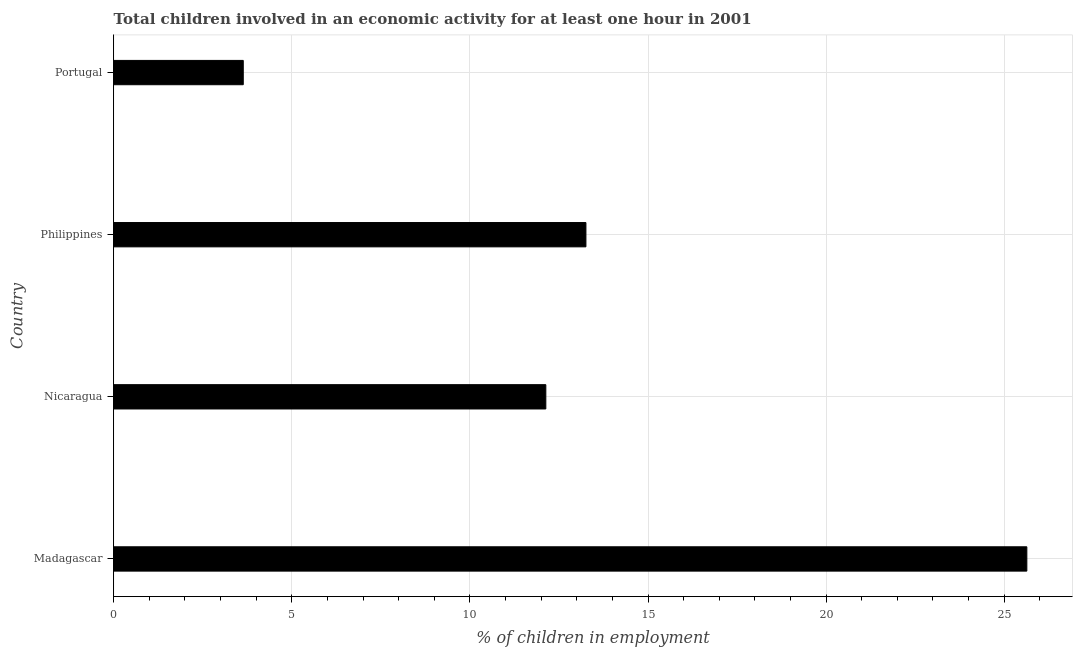Does the graph contain any zero values?
Offer a terse response. No. What is the title of the graph?
Your answer should be very brief. Total children involved in an economic activity for at least one hour in 2001. What is the label or title of the X-axis?
Make the answer very short. % of children in employment. What is the label or title of the Y-axis?
Your response must be concise. Country. What is the percentage of children in employment in Philippines?
Make the answer very short. 13.26. Across all countries, what is the maximum percentage of children in employment?
Keep it short and to the point. 25.63. Across all countries, what is the minimum percentage of children in employment?
Make the answer very short. 3.64. In which country was the percentage of children in employment maximum?
Your answer should be compact. Madagascar. What is the sum of the percentage of children in employment?
Ensure brevity in your answer.  54.66. What is the difference between the percentage of children in employment in Madagascar and Nicaragua?
Ensure brevity in your answer.  13.5. What is the average percentage of children in employment per country?
Make the answer very short. 13.66. What is the median percentage of children in employment?
Provide a short and direct response. 12.69. In how many countries, is the percentage of children in employment greater than 18 %?
Provide a short and direct response. 1. What is the ratio of the percentage of children in employment in Madagascar to that in Nicaragua?
Offer a very short reply. 2.11. Is the percentage of children in employment in Philippines less than that in Portugal?
Provide a succinct answer. No. What is the difference between the highest and the second highest percentage of children in employment?
Offer a very short reply. 12.38. Is the sum of the percentage of children in employment in Madagascar and Portugal greater than the maximum percentage of children in employment across all countries?
Give a very brief answer. Yes. What is the difference between the highest and the lowest percentage of children in employment?
Keep it short and to the point. 22. In how many countries, is the percentage of children in employment greater than the average percentage of children in employment taken over all countries?
Offer a very short reply. 1. How many bars are there?
Your answer should be compact. 4. How many countries are there in the graph?
Keep it short and to the point. 4. What is the difference between two consecutive major ticks on the X-axis?
Give a very brief answer. 5. What is the % of children in employment of Madagascar?
Offer a very short reply. 25.63. What is the % of children in employment in Nicaragua?
Provide a succinct answer. 12.13. What is the % of children in employment of Philippines?
Ensure brevity in your answer.  13.26. What is the % of children in employment of Portugal?
Your answer should be very brief. 3.64. What is the difference between the % of children in employment in Madagascar and Nicaragua?
Your response must be concise. 13.5. What is the difference between the % of children in employment in Madagascar and Philippines?
Your answer should be very brief. 12.38. What is the difference between the % of children in employment in Madagascar and Portugal?
Provide a short and direct response. 22. What is the difference between the % of children in employment in Nicaragua and Philippines?
Your answer should be very brief. -1.13. What is the difference between the % of children in employment in Nicaragua and Portugal?
Offer a terse response. 8.49. What is the difference between the % of children in employment in Philippines and Portugal?
Offer a terse response. 9.62. What is the ratio of the % of children in employment in Madagascar to that in Nicaragua?
Your answer should be compact. 2.11. What is the ratio of the % of children in employment in Madagascar to that in Philippines?
Ensure brevity in your answer.  1.93. What is the ratio of the % of children in employment in Madagascar to that in Portugal?
Ensure brevity in your answer.  7.05. What is the ratio of the % of children in employment in Nicaragua to that in Philippines?
Give a very brief answer. 0.92. What is the ratio of the % of children in employment in Nicaragua to that in Portugal?
Your answer should be compact. 3.34. What is the ratio of the % of children in employment in Philippines to that in Portugal?
Your response must be concise. 3.65. 